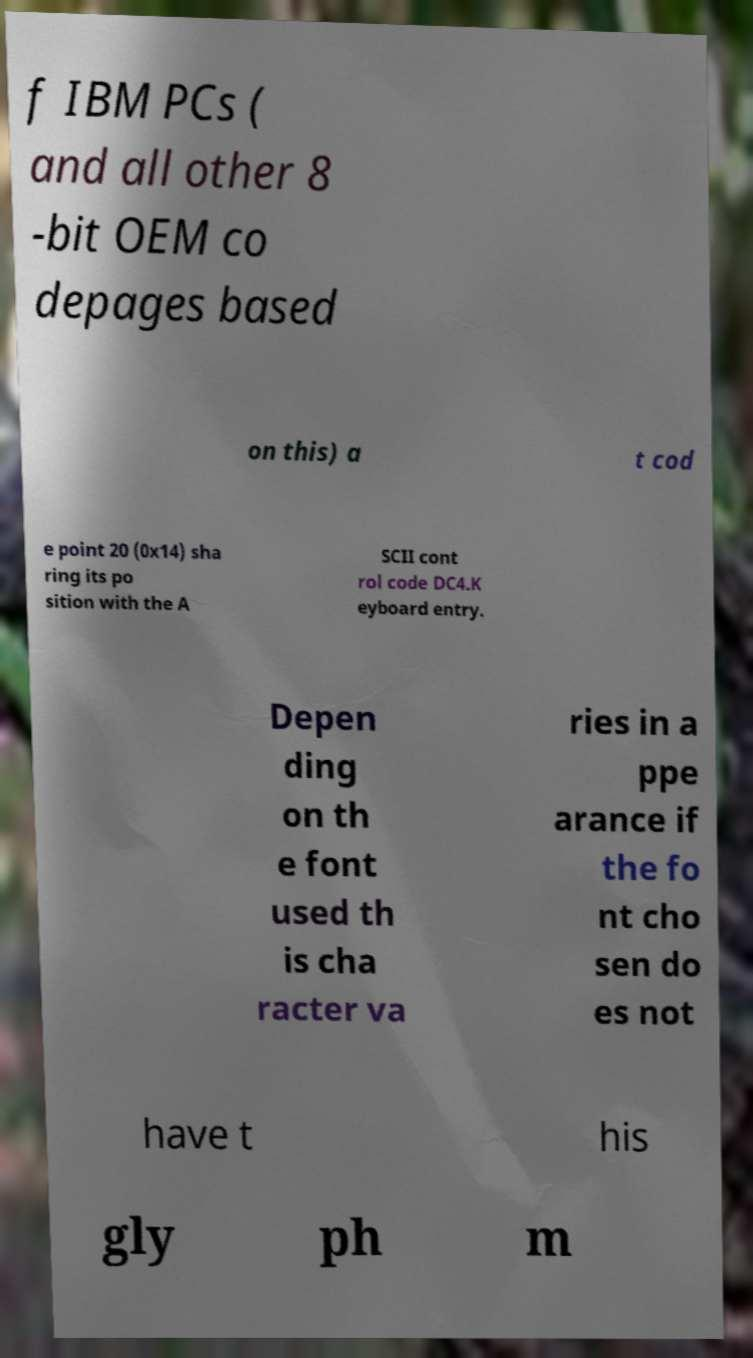Can you accurately transcribe the text from the provided image for me? f IBM PCs ( and all other 8 -bit OEM co depages based on this) a t cod e point 20 (0x14) sha ring its po sition with the A SCII cont rol code DC4.K eyboard entry. Depen ding on th e font used th is cha racter va ries in a ppe arance if the fo nt cho sen do es not have t his gly ph m 